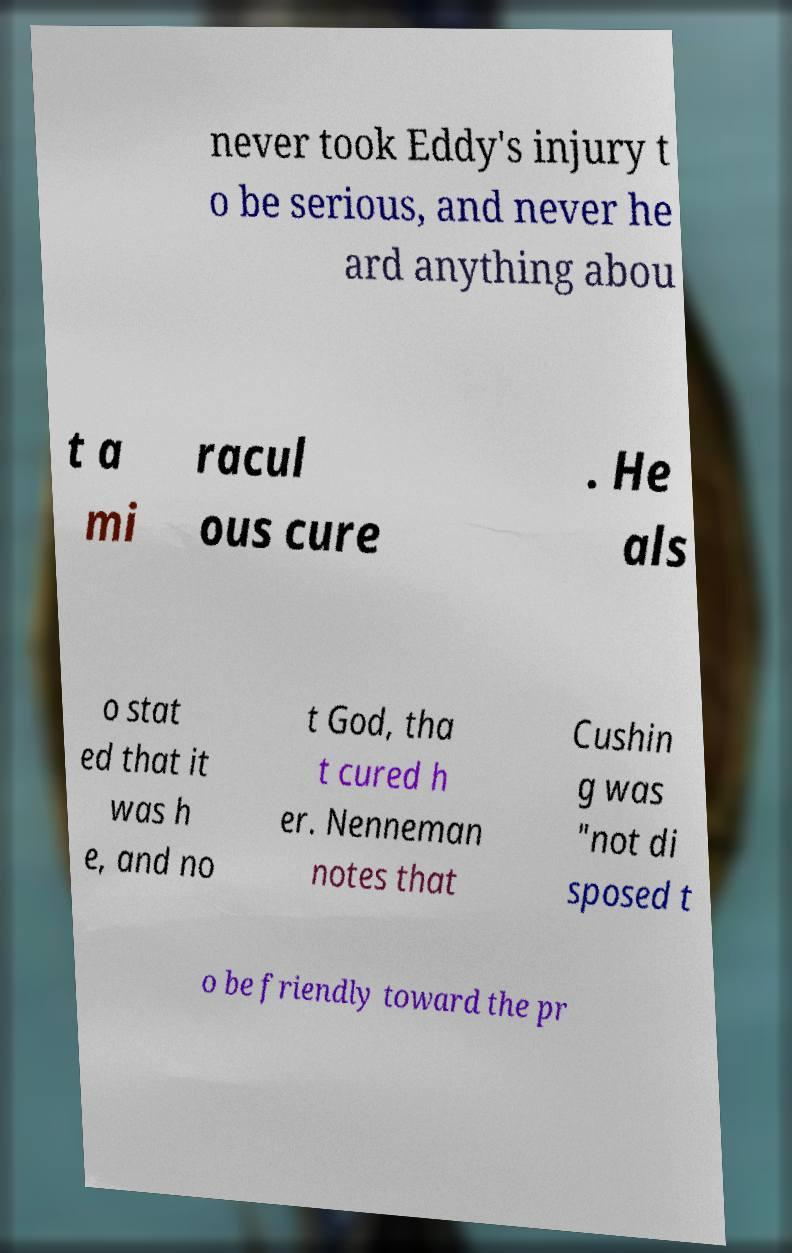There's text embedded in this image that I need extracted. Can you transcribe it verbatim? never took Eddy's injury t o be serious, and never he ard anything abou t a mi racul ous cure . He als o stat ed that it was h e, and no t God, tha t cured h er. Nenneman notes that Cushin g was "not di sposed t o be friendly toward the pr 